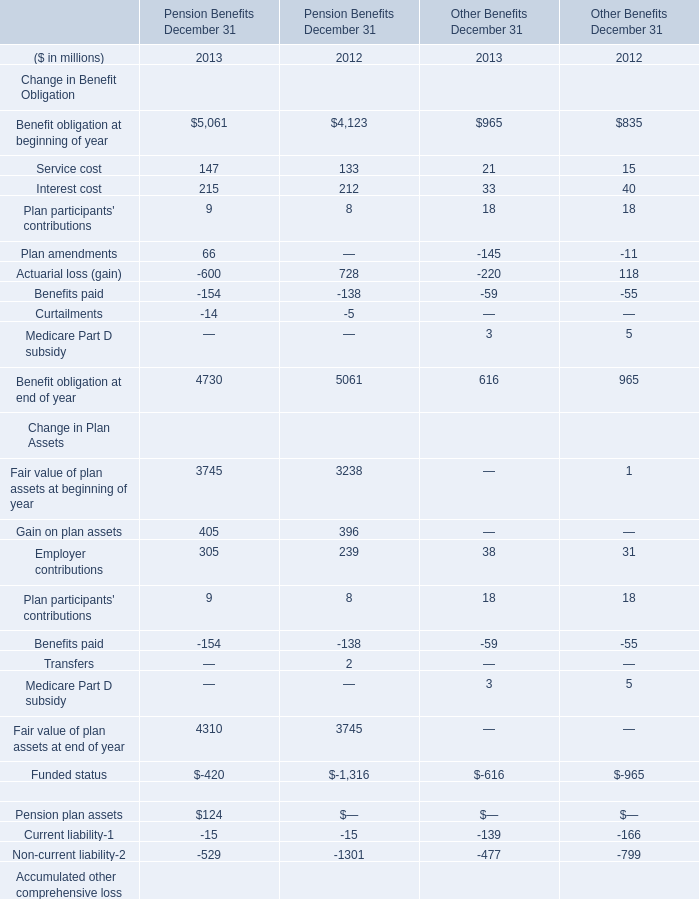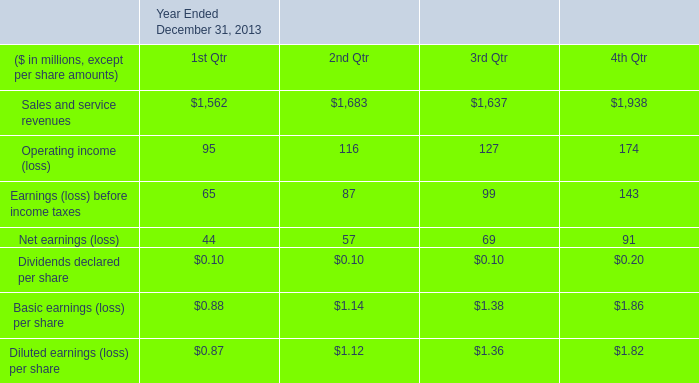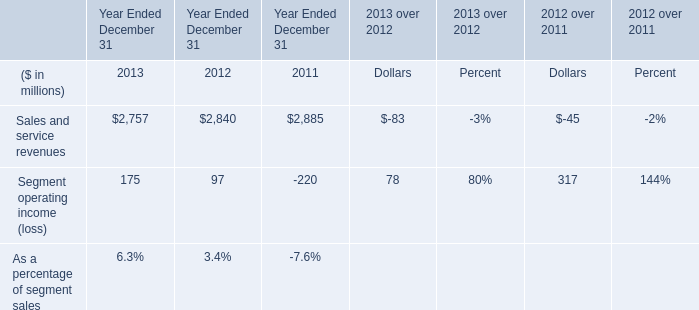What was the total amount of Employer contributions in the range of 0 and 500 in 2013? (in million) 
Computations: (305 + 38)
Answer: 343.0. 